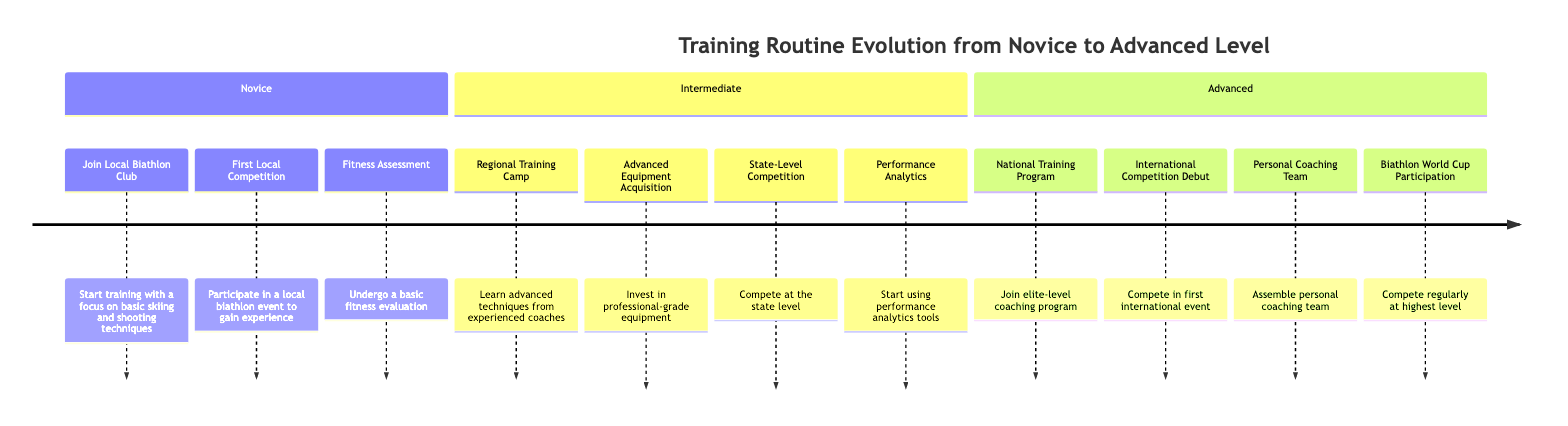What is the first milestone in the Novice stage? The first milestone is "Join Local Biathlon Club". This can be found by looking at the milestones listed under the Novice section of the timeline.
Answer: Join Local Biathlon Club How many milestones are there in the Intermediate stage? In the Intermediate stage, there are four milestones listed: Regional Training Camp, Advanced Equipment Acquisition, State-Level Competition, and Performance Analytics. Counting these provides the answer.
Answer: 4 What milestone comes after the "First Local Competition"? The milestone that comes after "First Local Competition" is "Fitness Assessment". This can be determined by looking at the order of milestones listed under the Novice section.
Answer: Fitness Assessment What is the last milestone in the Advanced stage? The last milestone in the Advanced stage is "Biathlon World Cup Participation". This can be identified by looking at the sequential listing of milestones in the Advanced section.
Answer: Biathlon World Cup Participation In which stage do you acquire advanced equipment? The acquisition of advanced equipment occurs in the Intermediate stage. This is based on the specific mention of "Advanced Equipment Acquisition" found under that section.
Answer: Intermediate How many total milestones are listed across all stages? Adding up all the milestones: Novice has 3, Intermediate has 4, and Advanced has 4, resulting in a total of 3 + 4 + 4 = 11 milestones.
Answer: 11 What is the third milestone in the Advanced stage? The third milestone in the Advanced stage is "Personal Coaching Team". By navigating through the milestones listed under the Advanced section, this can be identified.
Answer: Personal Coaching Team Which competition is highlighted in the Intermediate stage? The competition highlighted in the Intermediate stage is the "State-Level Competition". This is explicitly stated as one of the milestones in that section.
Answer: State-Level Competition What leads to joining the National Training Program? Qualifying for the National Training Program allows joining elite-level coaching. The pathway to this milestone can be inferred from the hierarchy of milestones presented in the Advanced stage.
Answer: Qualify for National Training Program 